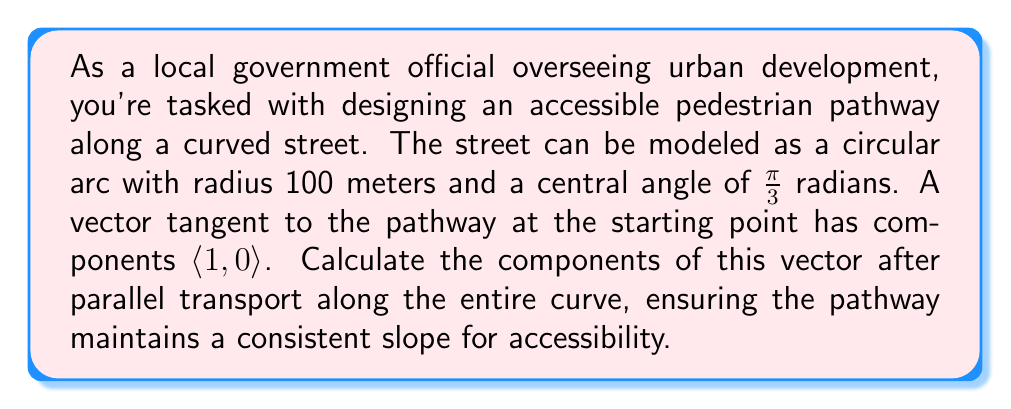Can you answer this question? Let's approach this step-by-step using concepts from differential geometry:

1) First, we need to understand that parallel transport preserves the angle between the transported vector and the curve's tangent vector.

2) For a circular arc, the angle of rotation of the tangent vector is equal to the central angle of the arc. In this case, it's $\frac{\pi}{3}$ radians or 60°.

3) The initial vector $\vec{v}_0 = \langle 1, 0 \rangle$ is tangent to the curve at the starting point.

4) To find the components of the vector after parallel transport, we need to rotate it by $\frac{\pi}{3}$ radians counterclockwise (as we're moving along the arc).

5) The rotation matrix for a counterclockwise rotation by angle $\theta$ is:

   $$R(\theta) = \begin{pmatrix} 
   \cos\theta & -\sin\theta \\ 
   \sin\theta & \cos\theta 
   \end{pmatrix}$$

6) Substituting $\theta = \frac{\pi}{3}$:

   $$R(\frac{\pi}{3}) = \begin{pmatrix} 
   \cos\frac{\pi}{3} & -\sin\frac{\pi}{3} \\ 
   \sin\frac{\pi}{3} & \cos\frac{\pi}{3} 
   \end{pmatrix} = \begin{pmatrix} 
   \frac{1}{2} & -\frac{\sqrt{3}}{2} \\ 
   \frac{\sqrt{3}}{2} & \frac{1}{2} 
   \end{pmatrix}$$

7) The final vector $\vec{v}_f$ after parallel transport is:

   $$\vec{v}_f = R(\frac{\pi}{3}) \vec{v}_0 = \begin{pmatrix} 
   \frac{1}{2} & -\frac{\sqrt{3}}{2} \\ 
   \frac{\sqrt{3}}{2} & \frac{1}{2} 
   \end{pmatrix} \begin{pmatrix} 
   1 \\ 
   0 
   \end{pmatrix} = \begin{pmatrix} 
   \frac{1}{2} \\ 
   \frac{\sqrt{3}}{2} 
   \end{pmatrix}$$

Therefore, the components of the vector after parallel transport are $\langle \frac{1}{2}, \frac{\sqrt{3}}{2} \rangle$.
Answer: $\langle \frac{1}{2}, \frac{\sqrt{3}}{2} \rangle$ 